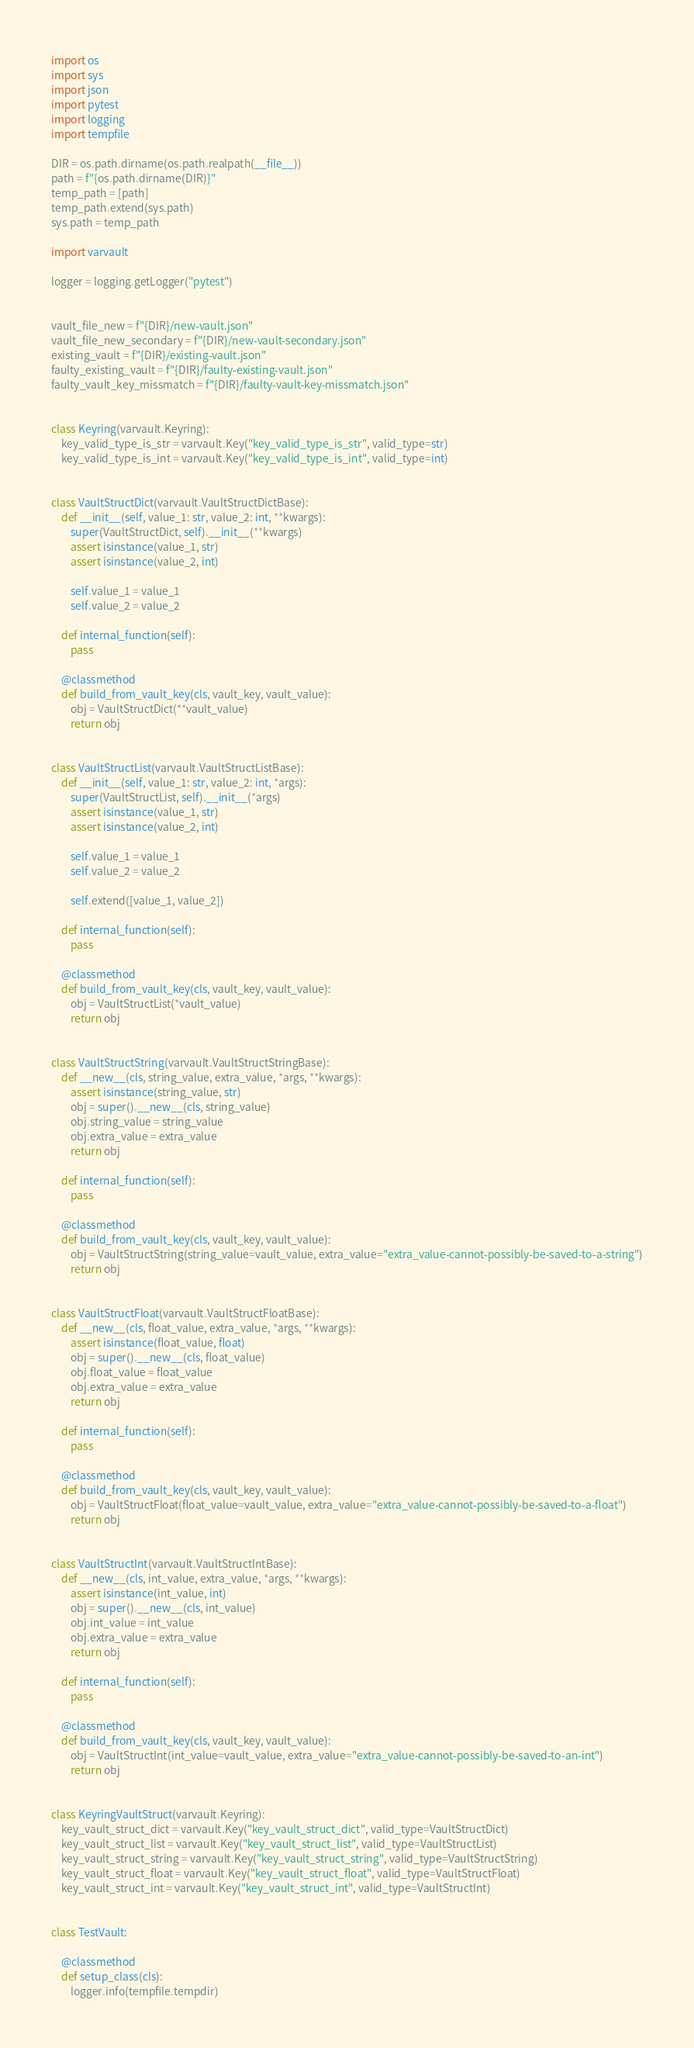<code> <loc_0><loc_0><loc_500><loc_500><_Python_>import os
import sys
import json
import pytest
import logging
import tempfile

DIR = os.path.dirname(os.path.realpath(__file__))
path = f"{os.path.dirname(DIR)}"
temp_path = [path]
temp_path.extend(sys.path)
sys.path = temp_path

import varvault

logger = logging.getLogger("pytest")


vault_file_new = f"{DIR}/new-vault.json"
vault_file_new_secondary = f"{DIR}/new-vault-secondary.json"
existing_vault = f"{DIR}/existing-vault.json"
faulty_existing_vault = f"{DIR}/faulty-existing-vault.json"
faulty_vault_key_missmatch = f"{DIR}/faulty-vault-key-missmatch.json"


class Keyring(varvault.Keyring):
    key_valid_type_is_str = varvault.Key("key_valid_type_is_str", valid_type=str)
    key_valid_type_is_int = varvault.Key("key_valid_type_is_int", valid_type=int)


class VaultStructDict(varvault.VaultStructDictBase):
    def __init__(self, value_1: str, value_2: int, **kwargs):
        super(VaultStructDict, self).__init__(**kwargs)
        assert isinstance(value_1, str)
        assert isinstance(value_2, int)

        self.value_1 = value_1
        self.value_2 = value_2

    def internal_function(self):
        pass

    @classmethod
    def build_from_vault_key(cls, vault_key, vault_value):
        obj = VaultStructDict(**vault_value)
        return obj


class VaultStructList(varvault.VaultStructListBase):
    def __init__(self, value_1: str, value_2: int, *args):
        super(VaultStructList, self).__init__(*args)
        assert isinstance(value_1, str)
        assert isinstance(value_2, int)

        self.value_1 = value_1
        self.value_2 = value_2

        self.extend([value_1, value_2])

    def internal_function(self):
        pass

    @classmethod
    def build_from_vault_key(cls, vault_key, vault_value):
        obj = VaultStructList(*vault_value)
        return obj


class VaultStructString(varvault.VaultStructStringBase):
    def __new__(cls, string_value, extra_value, *args, **kwargs):
        assert isinstance(string_value, str)
        obj = super().__new__(cls, string_value)
        obj.string_value = string_value
        obj.extra_value = extra_value
        return obj

    def internal_function(self):
        pass

    @classmethod
    def build_from_vault_key(cls, vault_key, vault_value):
        obj = VaultStructString(string_value=vault_value, extra_value="extra_value-cannot-possibly-be-saved-to-a-string")
        return obj


class VaultStructFloat(varvault.VaultStructFloatBase):
    def __new__(cls, float_value, extra_value, *args, **kwargs):
        assert isinstance(float_value, float)
        obj = super().__new__(cls, float_value)
        obj.float_value = float_value
        obj.extra_value = extra_value
        return obj

    def internal_function(self):
        pass

    @classmethod
    def build_from_vault_key(cls, vault_key, vault_value):
        obj = VaultStructFloat(float_value=vault_value, extra_value="extra_value-cannot-possibly-be-saved-to-a-float")
        return obj


class VaultStructInt(varvault.VaultStructIntBase):
    def __new__(cls, int_value, extra_value, *args, **kwargs):
        assert isinstance(int_value, int)
        obj = super().__new__(cls, int_value)
        obj.int_value = int_value
        obj.extra_value = extra_value
        return obj

    def internal_function(self):
        pass

    @classmethod
    def build_from_vault_key(cls, vault_key, vault_value):
        obj = VaultStructInt(int_value=vault_value, extra_value="extra_value-cannot-possibly-be-saved-to-an-int")
        return obj


class KeyringVaultStruct(varvault.Keyring):
    key_vault_struct_dict = varvault.Key("key_vault_struct_dict", valid_type=VaultStructDict)
    key_vault_struct_list = varvault.Key("key_vault_struct_list", valid_type=VaultStructList)
    key_vault_struct_string = varvault.Key("key_vault_struct_string", valid_type=VaultStructString)
    key_vault_struct_float = varvault.Key("key_vault_struct_float", valid_type=VaultStructFloat)
    key_vault_struct_int = varvault.Key("key_vault_struct_int", valid_type=VaultStructInt)


class TestVault:

    @classmethod
    def setup_class(cls):
        logger.info(tempfile.tempdir)</code> 